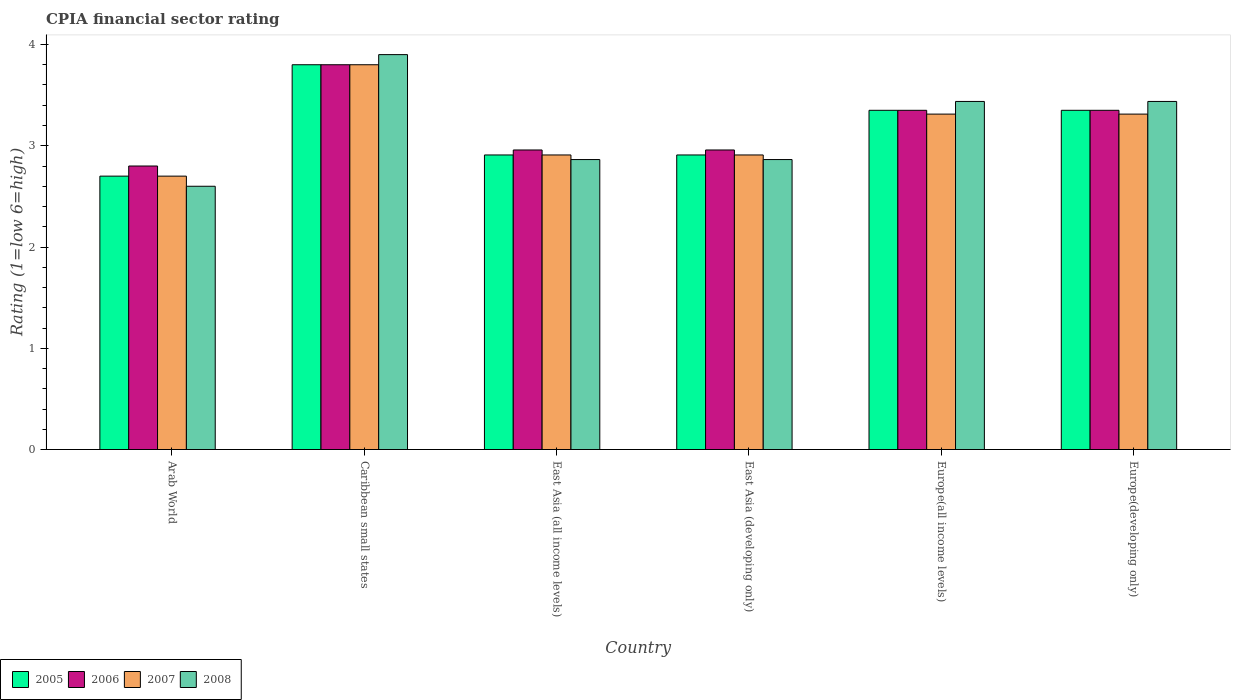How many groups of bars are there?
Give a very brief answer. 6. Are the number of bars per tick equal to the number of legend labels?
Keep it short and to the point. Yes. Are the number of bars on each tick of the X-axis equal?
Offer a terse response. Yes. How many bars are there on the 2nd tick from the right?
Make the answer very short. 4. What is the label of the 6th group of bars from the left?
Offer a terse response. Europe(developing only). What is the CPIA rating in 2008 in Europe(developing only)?
Provide a succinct answer. 3.44. Across all countries, what is the minimum CPIA rating in 2005?
Your answer should be very brief. 2.7. In which country was the CPIA rating in 2008 maximum?
Provide a short and direct response. Caribbean small states. In which country was the CPIA rating in 2006 minimum?
Ensure brevity in your answer.  Arab World. What is the total CPIA rating in 2008 in the graph?
Offer a terse response. 19.1. What is the difference between the CPIA rating in 2008 in Europe(developing only) and the CPIA rating in 2005 in Caribbean small states?
Offer a terse response. -0.36. What is the average CPIA rating in 2005 per country?
Keep it short and to the point. 3.17. What is the difference between the CPIA rating of/in 2008 and CPIA rating of/in 2007 in East Asia (all income levels)?
Offer a terse response. -0.05. What is the ratio of the CPIA rating in 2006 in Arab World to that in Caribbean small states?
Give a very brief answer. 0.74. Is the difference between the CPIA rating in 2008 in Caribbean small states and Europe(developing only) greater than the difference between the CPIA rating in 2007 in Caribbean small states and Europe(developing only)?
Keep it short and to the point. No. What is the difference between the highest and the second highest CPIA rating in 2008?
Give a very brief answer. -0.46. What is the difference between the highest and the lowest CPIA rating in 2005?
Your response must be concise. 1.1. Is the sum of the CPIA rating in 2006 in Arab World and Europe(all income levels) greater than the maximum CPIA rating in 2008 across all countries?
Provide a short and direct response. Yes. Is it the case that in every country, the sum of the CPIA rating in 2008 and CPIA rating in 2006 is greater than the sum of CPIA rating in 2007 and CPIA rating in 2005?
Provide a succinct answer. No. What does the 2nd bar from the left in East Asia (all income levels) represents?
Give a very brief answer. 2006. What does the 2nd bar from the right in Europe(developing only) represents?
Make the answer very short. 2007. How many bars are there?
Your response must be concise. 24. What is the difference between two consecutive major ticks on the Y-axis?
Make the answer very short. 1. Does the graph contain grids?
Your response must be concise. No. How are the legend labels stacked?
Keep it short and to the point. Horizontal. What is the title of the graph?
Make the answer very short. CPIA financial sector rating. Does "2003" appear as one of the legend labels in the graph?
Offer a terse response. No. What is the label or title of the X-axis?
Ensure brevity in your answer.  Country. What is the Rating (1=low 6=high) of 2005 in Arab World?
Offer a very short reply. 2.7. What is the Rating (1=low 6=high) of 2006 in Caribbean small states?
Give a very brief answer. 3.8. What is the Rating (1=low 6=high) of 2005 in East Asia (all income levels)?
Offer a terse response. 2.91. What is the Rating (1=low 6=high) in 2006 in East Asia (all income levels)?
Keep it short and to the point. 2.96. What is the Rating (1=low 6=high) in 2007 in East Asia (all income levels)?
Provide a short and direct response. 2.91. What is the Rating (1=low 6=high) in 2008 in East Asia (all income levels)?
Offer a terse response. 2.86. What is the Rating (1=low 6=high) of 2005 in East Asia (developing only)?
Provide a short and direct response. 2.91. What is the Rating (1=low 6=high) of 2006 in East Asia (developing only)?
Give a very brief answer. 2.96. What is the Rating (1=low 6=high) of 2007 in East Asia (developing only)?
Keep it short and to the point. 2.91. What is the Rating (1=low 6=high) of 2008 in East Asia (developing only)?
Offer a very short reply. 2.86. What is the Rating (1=low 6=high) of 2005 in Europe(all income levels)?
Give a very brief answer. 3.35. What is the Rating (1=low 6=high) in 2006 in Europe(all income levels)?
Provide a short and direct response. 3.35. What is the Rating (1=low 6=high) in 2007 in Europe(all income levels)?
Offer a terse response. 3.31. What is the Rating (1=low 6=high) in 2008 in Europe(all income levels)?
Offer a very short reply. 3.44. What is the Rating (1=low 6=high) of 2005 in Europe(developing only)?
Your response must be concise. 3.35. What is the Rating (1=low 6=high) in 2006 in Europe(developing only)?
Your answer should be very brief. 3.35. What is the Rating (1=low 6=high) of 2007 in Europe(developing only)?
Your answer should be compact. 3.31. What is the Rating (1=low 6=high) in 2008 in Europe(developing only)?
Provide a short and direct response. 3.44. Across all countries, what is the maximum Rating (1=low 6=high) in 2007?
Give a very brief answer. 3.8. Across all countries, what is the maximum Rating (1=low 6=high) of 2008?
Give a very brief answer. 3.9. Across all countries, what is the minimum Rating (1=low 6=high) in 2005?
Offer a terse response. 2.7. Across all countries, what is the minimum Rating (1=low 6=high) of 2008?
Your answer should be very brief. 2.6. What is the total Rating (1=low 6=high) in 2005 in the graph?
Make the answer very short. 19.02. What is the total Rating (1=low 6=high) of 2006 in the graph?
Keep it short and to the point. 19.22. What is the total Rating (1=low 6=high) of 2007 in the graph?
Your response must be concise. 18.94. What is the total Rating (1=low 6=high) in 2008 in the graph?
Your answer should be compact. 19.1. What is the difference between the Rating (1=low 6=high) in 2007 in Arab World and that in Caribbean small states?
Keep it short and to the point. -1.1. What is the difference between the Rating (1=low 6=high) in 2008 in Arab World and that in Caribbean small states?
Your response must be concise. -1.3. What is the difference between the Rating (1=low 6=high) in 2005 in Arab World and that in East Asia (all income levels)?
Your response must be concise. -0.21. What is the difference between the Rating (1=low 6=high) in 2006 in Arab World and that in East Asia (all income levels)?
Provide a succinct answer. -0.16. What is the difference between the Rating (1=low 6=high) in 2007 in Arab World and that in East Asia (all income levels)?
Ensure brevity in your answer.  -0.21. What is the difference between the Rating (1=low 6=high) in 2008 in Arab World and that in East Asia (all income levels)?
Give a very brief answer. -0.26. What is the difference between the Rating (1=low 6=high) of 2005 in Arab World and that in East Asia (developing only)?
Provide a succinct answer. -0.21. What is the difference between the Rating (1=low 6=high) of 2006 in Arab World and that in East Asia (developing only)?
Your answer should be very brief. -0.16. What is the difference between the Rating (1=low 6=high) of 2007 in Arab World and that in East Asia (developing only)?
Your answer should be very brief. -0.21. What is the difference between the Rating (1=low 6=high) in 2008 in Arab World and that in East Asia (developing only)?
Provide a short and direct response. -0.26. What is the difference between the Rating (1=low 6=high) in 2005 in Arab World and that in Europe(all income levels)?
Provide a succinct answer. -0.65. What is the difference between the Rating (1=low 6=high) of 2006 in Arab World and that in Europe(all income levels)?
Keep it short and to the point. -0.55. What is the difference between the Rating (1=low 6=high) in 2007 in Arab World and that in Europe(all income levels)?
Your answer should be compact. -0.61. What is the difference between the Rating (1=low 6=high) of 2008 in Arab World and that in Europe(all income levels)?
Your answer should be compact. -0.84. What is the difference between the Rating (1=low 6=high) in 2005 in Arab World and that in Europe(developing only)?
Provide a short and direct response. -0.65. What is the difference between the Rating (1=low 6=high) in 2006 in Arab World and that in Europe(developing only)?
Provide a short and direct response. -0.55. What is the difference between the Rating (1=low 6=high) in 2007 in Arab World and that in Europe(developing only)?
Your answer should be very brief. -0.61. What is the difference between the Rating (1=low 6=high) of 2008 in Arab World and that in Europe(developing only)?
Your response must be concise. -0.84. What is the difference between the Rating (1=low 6=high) in 2005 in Caribbean small states and that in East Asia (all income levels)?
Offer a very short reply. 0.89. What is the difference between the Rating (1=low 6=high) in 2006 in Caribbean small states and that in East Asia (all income levels)?
Your answer should be very brief. 0.84. What is the difference between the Rating (1=low 6=high) in 2007 in Caribbean small states and that in East Asia (all income levels)?
Your answer should be compact. 0.89. What is the difference between the Rating (1=low 6=high) of 2008 in Caribbean small states and that in East Asia (all income levels)?
Keep it short and to the point. 1.04. What is the difference between the Rating (1=low 6=high) in 2005 in Caribbean small states and that in East Asia (developing only)?
Keep it short and to the point. 0.89. What is the difference between the Rating (1=low 6=high) in 2006 in Caribbean small states and that in East Asia (developing only)?
Give a very brief answer. 0.84. What is the difference between the Rating (1=low 6=high) of 2007 in Caribbean small states and that in East Asia (developing only)?
Make the answer very short. 0.89. What is the difference between the Rating (1=low 6=high) of 2008 in Caribbean small states and that in East Asia (developing only)?
Provide a succinct answer. 1.04. What is the difference between the Rating (1=low 6=high) of 2005 in Caribbean small states and that in Europe(all income levels)?
Ensure brevity in your answer.  0.45. What is the difference between the Rating (1=low 6=high) of 2006 in Caribbean small states and that in Europe(all income levels)?
Keep it short and to the point. 0.45. What is the difference between the Rating (1=low 6=high) of 2007 in Caribbean small states and that in Europe(all income levels)?
Your answer should be very brief. 0.49. What is the difference between the Rating (1=low 6=high) in 2008 in Caribbean small states and that in Europe(all income levels)?
Provide a short and direct response. 0.46. What is the difference between the Rating (1=low 6=high) in 2005 in Caribbean small states and that in Europe(developing only)?
Provide a short and direct response. 0.45. What is the difference between the Rating (1=low 6=high) of 2006 in Caribbean small states and that in Europe(developing only)?
Ensure brevity in your answer.  0.45. What is the difference between the Rating (1=low 6=high) of 2007 in Caribbean small states and that in Europe(developing only)?
Offer a very short reply. 0.49. What is the difference between the Rating (1=low 6=high) in 2008 in Caribbean small states and that in Europe(developing only)?
Offer a terse response. 0.46. What is the difference between the Rating (1=low 6=high) of 2005 in East Asia (all income levels) and that in East Asia (developing only)?
Offer a terse response. 0. What is the difference between the Rating (1=low 6=high) in 2006 in East Asia (all income levels) and that in East Asia (developing only)?
Ensure brevity in your answer.  0. What is the difference between the Rating (1=low 6=high) in 2007 in East Asia (all income levels) and that in East Asia (developing only)?
Keep it short and to the point. 0. What is the difference between the Rating (1=low 6=high) of 2008 in East Asia (all income levels) and that in East Asia (developing only)?
Offer a very short reply. 0. What is the difference between the Rating (1=low 6=high) in 2005 in East Asia (all income levels) and that in Europe(all income levels)?
Provide a succinct answer. -0.44. What is the difference between the Rating (1=low 6=high) in 2006 in East Asia (all income levels) and that in Europe(all income levels)?
Your answer should be very brief. -0.39. What is the difference between the Rating (1=low 6=high) in 2007 in East Asia (all income levels) and that in Europe(all income levels)?
Offer a terse response. -0.4. What is the difference between the Rating (1=low 6=high) of 2008 in East Asia (all income levels) and that in Europe(all income levels)?
Offer a very short reply. -0.57. What is the difference between the Rating (1=low 6=high) in 2005 in East Asia (all income levels) and that in Europe(developing only)?
Offer a terse response. -0.44. What is the difference between the Rating (1=low 6=high) of 2006 in East Asia (all income levels) and that in Europe(developing only)?
Your answer should be compact. -0.39. What is the difference between the Rating (1=low 6=high) of 2007 in East Asia (all income levels) and that in Europe(developing only)?
Offer a terse response. -0.4. What is the difference between the Rating (1=low 6=high) of 2008 in East Asia (all income levels) and that in Europe(developing only)?
Ensure brevity in your answer.  -0.57. What is the difference between the Rating (1=low 6=high) of 2005 in East Asia (developing only) and that in Europe(all income levels)?
Offer a terse response. -0.44. What is the difference between the Rating (1=low 6=high) in 2006 in East Asia (developing only) and that in Europe(all income levels)?
Give a very brief answer. -0.39. What is the difference between the Rating (1=low 6=high) in 2007 in East Asia (developing only) and that in Europe(all income levels)?
Your answer should be very brief. -0.4. What is the difference between the Rating (1=low 6=high) of 2008 in East Asia (developing only) and that in Europe(all income levels)?
Make the answer very short. -0.57. What is the difference between the Rating (1=low 6=high) of 2005 in East Asia (developing only) and that in Europe(developing only)?
Offer a very short reply. -0.44. What is the difference between the Rating (1=low 6=high) in 2006 in East Asia (developing only) and that in Europe(developing only)?
Provide a succinct answer. -0.39. What is the difference between the Rating (1=low 6=high) in 2007 in East Asia (developing only) and that in Europe(developing only)?
Offer a terse response. -0.4. What is the difference between the Rating (1=low 6=high) of 2008 in East Asia (developing only) and that in Europe(developing only)?
Your answer should be very brief. -0.57. What is the difference between the Rating (1=low 6=high) of 2008 in Europe(all income levels) and that in Europe(developing only)?
Offer a terse response. 0. What is the difference between the Rating (1=low 6=high) of 2005 in Arab World and the Rating (1=low 6=high) of 2006 in Caribbean small states?
Your response must be concise. -1.1. What is the difference between the Rating (1=low 6=high) in 2006 in Arab World and the Rating (1=low 6=high) in 2007 in Caribbean small states?
Keep it short and to the point. -1. What is the difference between the Rating (1=low 6=high) in 2005 in Arab World and the Rating (1=low 6=high) in 2006 in East Asia (all income levels)?
Ensure brevity in your answer.  -0.26. What is the difference between the Rating (1=low 6=high) in 2005 in Arab World and the Rating (1=low 6=high) in 2007 in East Asia (all income levels)?
Give a very brief answer. -0.21. What is the difference between the Rating (1=low 6=high) of 2005 in Arab World and the Rating (1=low 6=high) of 2008 in East Asia (all income levels)?
Provide a succinct answer. -0.16. What is the difference between the Rating (1=low 6=high) in 2006 in Arab World and the Rating (1=low 6=high) in 2007 in East Asia (all income levels)?
Your answer should be compact. -0.11. What is the difference between the Rating (1=low 6=high) in 2006 in Arab World and the Rating (1=low 6=high) in 2008 in East Asia (all income levels)?
Keep it short and to the point. -0.06. What is the difference between the Rating (1=low 6=high) of 2007 in Arab World and the Rating (1=low 6=high) of 2008 in East Asia (all income levels)?
Provide a short and direct response. -0.16. What is the difference between the Rating (1=low 6=high) of 2005 in Arab World and the Rating (1=low 6=high) of 2006 in East Asia (developing only)?
Offer a very short reply. -0.26. What is the difference between the Rating (1=low 6=high) in 2005 in Arab World and the Rating (1=low 6=high) in 2007 in East Asia (developing only)?
Offer a terse response. -0.21. What is the difference between the Rating (1=low 6=high) of 2005 in Arab World and the Rating (1=low 6=high) of 2008 in East Asia (developing only)?
Your answer should be compact. -0.16. What is the difference between the Rating (1=low 6=high) of 2006 in Arab World and the Rating (1=low 6=high) of 2007 in East Asia (developing only)?
Your answer should be compact. -0.11. What is the difference between the Rating (1=low 6=high) in 2006 in Arab World and the Rating (1=low 6=high) in 2008 in East Asia (developing only)?
Provide a succinct answer. -0.06. What is the difference between the Rating (1=low 6=high) of 2007 in Arab World and the Rating (1=low 6=high) of 2008 in East Asia (developing only)?
Your answer should be very brief. -0.16. What is the difference between the Rating (1=low 6=high) in 2005 in Arab World and the Rating (1=low 6=high) in 2006 in Europe(all income levels)?
Give a very brief answer. -0.65. What is the difference between the Rating (1=low 6=high) in 2005 in Arab World and the Rating (1=low 6=high) in 2007 in Europe(all income levels)?
Provide a short and direct response. -0.61. What is the difference between the Rating (1=low 6=high) of 2005 in Arab World and the Rating (1=low 6=high) of 2008 in Europe(all income levels)?
Offer a very short reply. -0.74. What is the difference between the Rating (1=low 6=high) in 2006 in Arab World and the Rating (1=low 6=high) in 2007 in Europe(all income levels)?
Offer a very short reply. -0.51. What is the difference between the Rating (1=low 6=high) of 2006 in Arab World and the Rating (1=low 6=high) of 2008 in Europe(all income levels)?
Your answer should be compact. -0.64. What is the difference between the Rating (1=low 6=high) of 2007 in Arab World and the Rating (1=low 6=high) of 2008 in Europe(all income levels)?
Provide a succinct answer. -0.74. What is the difference between the Rating (1=low 6=high) in 2005 in Arab World and the Rating (1=low 6=high) in 2006 in Europe(developing only)?
Ensure brevity in your answer.  -0.65. What is the difference between the Rating (1=low 6=high) of 2005 in Arab World and the Rating (1=low 6=high) of 2007 in Europe(developing only)?
Make the answer very short. -0.61. What is the difference between the Rating (1=low 6=high) of 2005 in Arab World and the Rating (1=low 6=high) of 2008 in Europe(developing only)?
Offer a terse response. -0.74. What is the difference between the Rating (1=low 6=high) in 2006 in Arab World and the Rating (1=low 6=high) in 2007 in Europe(developing only)?
Your answer should be very brief. -0.51. What is the difference between the Rating (1=low 6=high) in 2006 in Arab World and the Rating (1=low 6=high) in 2008 in Europe(developing only)?
Your response must be concise. -0.64. What is the difference between the Rating (1=low 6=high) of 2007 in Arab World and the Rating (1=low 6=high) of 2008 in Europe(developing only)?
Your answer should be compact. -0.74. What is the difference between the Rating (1=low 6=high) in 2005 in Caribbean small states and the Rating (1=low 6=high) in 2006 in East Asia (all income levels)?
Your response must be concise. 0.84. What is the difference between the Rating (1=low 6=high) in 2005 in Caribbean small states and the Rating (1=low 6=high) in 2007 in East Asia (all income levels)?
Provide a short and direct response. 0.89. What is the difference between the Rating (1=low 6=high) in 2005 in Caribbean small states and the Rating (1=low 6=high) in 2008 in East Asia (all income levels)?
Provide a succinct answer. 0.94. What is the difference between the Rating (1=low 6=high) of 2006 in Caribbean small states and the Rating (1=low 6=high) of 2007 in East Asia (all income levels)?
Make the answer very short. 0.89. What is the difference between the Rating (1=low 6=high) in 2006 in Caribbean small states and the Rating (1=low 6=high) in 2008 in East Asia (all income levels)?
Give a very brief answer. 0.94. What is the difference between the Rating (1=low 6=high) in 2007 in Caribbean small states and the Rating (1=low 6=high) in 2008 in East Asia (all income levels)?
Offer a very short reply. 0.94. What is the difference between the Rating (1=low 6=high) of 2005 in Caribbean small states and the Rating (1=low 6=high) of 2006 in East Asia (developing only)?
Ensure brevity in your answer.  0.84. What is the difference between the Rating (1=low 6=high) of 2005 in Caribbean small states and the Rating (1=low 6=high) of 2007 in East Asia (developing only)?
Your answer should be compact. 0.89. What is the difference between the Rating (1=low 6=high) of 2005 in Caribbean small states and the Rating (1=low 6=high) of 2008 in East Asia (developing only)?
Offer a terse response. 0.94. What is the difference between the Rating (1=low 6=high) in 2006 in Caribbean small states and the Rating (1=low 6=high) in 2007 in East Asia (developing only)?
Ensure brevity in your answer.  0.89. What is the difference between the Rating (1=low 6=high) in 2006 in Caribbean small states and the Rating (1=low 6=high) in 2008 in East Asia (developing only)?
Your answer should be compact. 0.94. What is the difference between the Rating (1=low 6=high) of 2007 in Caribbean small states and the Rating (1=low 6=high) of 2008 in East Asia (developing only)?
Offer a very short reply. 0.94. What is the difference between the Rating (1=low 6=high) in 2005 in Caribbean small states and the Rating (1=low 6=high) in 2006 in Europe(all income levels)?
Your response must be concise. 0.45. What is the difference between the Rating (1=low 6=high) of 2005 in Caribbean small states and the Rating (1=low 6=high) of 2007 in Europe(all income levels)?
Your response must be concise. 0.49. What is the difference between the Rating (1=low 6=high) in 2005 in Caribbean small states and the Rating (1=low 6=high) in 2008 in Europe(all income levels)?
Provide a succinct answer. 0.36. What is the difference between the Rating (1=low 6=high) of 2006 in Caribbean small states and the Rating (1=low 6=high) of 2007 in Europe(all income levels)?
Give a very brief answer. 0.49. What is the difference between the Rating (1=low 6=high) of 2006 in Caribbean small states and the Rating (1=low 6=high) of 2008 in Europe(all income levels)?
Your response must be concise. 0.36. What is the difference between the Rating (1=low 6=high) of 2007 in Caribbean small states and the Rating (1=low 6=high) of 2008 in Europe(all income levels)?
Keep it short and to the point. 0.36. What is the difference between the Rating (1=low 6=high) of 2005 in Caribbean small states and the Rating (1=low 6=high) of 2006 in Europe(developing only)?
Your answer should be compact. 0.45. What is the difference between the Rating (1=low 6=high) of 2005 in Caribbean small states and the Rating (1=low 6=high) of 2007 in Europe(developing only)?
Make the answer very short. 0.49. What is the difference between the Rating (1=low 6=high) of 2005 in Caribbean small states and the Rating (1=low 6=high) of 2008 in Europe(developing only)?
Keep it short and to the point. 0.36. What is the difference between the Rating (1=low 6=high) in 2006 in Caribbean small states and the Rating (1=low 6=high) in 2007 in Europe(developing only)?
Keep it short and to the point. 0.49. What is the difference between the Rating (1=low 6=high) of 2006 in Caribbean small states and the Rating (1=low 6=high) of 2008 in Europe(developing only)?
Provide a short and direct response. 0.36. What is the difference between the Rating (1=low 6=high) in 2007 in Caribbean small states and the Rating (1=low 6=high) in 2008 in Europe(developing only)?
Keep it short and to the point. 0.36. What is the difference between the Rating (1=low 6=high) of 2005 in East Asia (all income levels) and the Rating (1=low 6=high) of 2006 in East Asia (developing only)?
Offer a very short reply. -0.05. What is the difference between the Rating (1=low 6=high) of 2005 in East Asia (all income levels) and the Rating (1=low 6=high) of 2007 in East Asia (developing only)?
Offer a terse response. 0. What is the difference between the Rating (1=low 6=high) of 2005 in East Asia (all income levels) and the Rating (1=low 6=high) of 2008 in East Asia (developing only)?
Your answer should be very brief. 0.05. What is the difference between the Rating (1=low 6=high) of 2006 in East Asia (all income levels) and the Rating (1=low 6=high) of 2007 in East Asia (developing only)?
Offer a very short reply. 0.05. What is the difference between the Rating (1=low 6=high) of 2006 in East Asia (all income levels) and the Rating (1=low 6=high) of 2008 in East Asia (developing only)?
Keep it short and to the point. 0.09. What is the difference between the Rating (1=low 6=high) in 2007 in East Asia (all income levels) and the Rating (1=low 6=high) in 2008 in East Asia (developing only)?
Provide a short and direct response. 0.05. What is the difference between the Rating (1=low 6=high) of 2005 in East Asia (all income levels) and the Rating (1=low 6=high) of 2006 in Europe(all income levels)?
Provide a succinct answer. -0.44. What is the difference between the Rating (1=low 6=high) in 2005 in East Asia (all income levels) and the Rating (1=low 6=high) in 2007 in Europe(all income levels)?
Ensure brevity in your answer.  -0.4. What is the difference between the Rating (1=low 6=high) of 2005 in East Asia (all income levels) and the Rating (1=low 6=high) of 2008 in Europe(all income levels)?
Offer a terse response. -0.53. What is the difference between the Rating (1=low 6=high) of 2006 in East Asia (all income levels) and the Rating (1=low 6=high) of 2007 in Europe(all income levels)?
Your response must be concise. -0.35. What is the difference between the Rating (1=low 6=high) in 2006 in East Asia (all income levels) and the Rating (1=low 6=high) in 2008 in Europe(all income levels)?
Your response must be concise. -0.48. What is the difference between the Rating (1=low 6=high) of 2007 in East Asia (all income levels) and the Rating (1=low 6=high) of 2008 in Europe(all income levels)?
Your response must be concise. -0.53. What is the difference between the Rating (1=low 6=high) of 2005 in East Asia (all income levels) and the Rating (1=low 6=high) of 2006 in Europe(developing only)?
Keep it short and to the point. -0.44. What is the difference between the Rating (1=low 6=high) of 2005 in East Asia (all income levels) and the Rating (1=low 6=high) of 2007 in Europe(developing only)?
Your response must be concise. -0.4. What is the difference between the Rating (1=low 6=high) of 2005 in East Asia (all income levels) and the Rating (1=low 6=high) of 2008 in Europe(developing only)?
Give a very brief answer. -0.53. What is the difference between the Rating (1=low 6=high) in 2006 in East Asia (all income levels) and the Rating (1=low 6=high) in 2007 in Europe(developing only)?
Give a very brief answer. -0.35. What is the difference between the Rating (1=low 6=high) of 2006 in East Asia (all income levels) and the Rating (1=low 6=high) of 2008 in Europe(developing only)?
Give a very brief answer. -0.48. What is the difference between the Rating (1=low 6=high) in 2007 in East Asia (all income levels) and the Rating (1=low 6=high) in 2008 in Europe(developing only)?
Offer a very short reply. -0.53. What is the difference between the Rating (1=low 6=high) of 2005 in East Asia (developing only) and the Rating (1=low 6=high) of 2006 in Europe(all income levels)?
Your answer should be compact. -0.44. What is the difference between the Rating (1=low 6=high) in 2005 in East Asia (developing only) and the Rating (1=low 6=high) in 2007 in Europe(all income levels)?
Keep it short and to the point. -0.4. What is the difference between the Rating (1=low 6=high) of 2005 in East Asia (developing only) and the Rating (1=low 6=high) of 2008 in Europe(all income levels)?
Offer a very short reply. -0.53. What is the difference between the Rating (1=low 6=high) in 2006 in East Asia (developing only) and the Rating (1=low 6=high) in 2007 in Europe(all income levels)?
Offer a very short reply. -0.35. What is the difference between the Rating (1=low 6=high) in 2006 in East Asia (developing only) and the Rating (1=low 6=high) in 2008 in Europe(all income levels)?
Offer a very short reply. -0.48. What is the difference between the Rating (1=low 6=high) of 2007 in East Asia (developing only) and the Rating (1=low 6=high) of 2008 in Europe(all income levels)?
Make the answer very short. -0.53. What is the difference between the Rating (1=low 6=high) in 2005 in East Asia (developing only) and the Rating (1=low 6=high) in 2006 in Europe(developing only)?
Offer a terse response. -0.44. What is the difference between the Rating (1=low 6=high) of 2005 in East Asia (developing only) and the Rating (1=low 6=high) of 2007 in Europe(developing only)?
Give a very brief answer. -0.4. What is the difference between the Rating (1=low 6=high) in 2005 in East Asia (developing only) and the Rating (1=low 6=high) in 2008 in Europe(developing only)?
Provide a succinct answer. -0.53. What is the difference between the Rating (1=low 6=high) in 2006 in East Asia (developing only) and the Rating (1=low 6=high) in 2007 in Europe(developing only)?
Your answer should be very brief. -0.35. What is the difference between the Rating (1=low 6=high) of 2006 in East Asia (developing only) and the Rating (1=low 6=high) of 2008 in Europe(developing only)?
Make the answer very short. -0.48. What is the difference between the Rating (1=low 6=high) in 2007 in East Asia (developing only) and the Rating (1=low 6=high) in 2008 in Europe(developing only)?
Provide a short and direct response. -0.53. What is the difference between the Rating (1=low 6=high) of 2005 in Europe(all income levels) and the Rating (1=low 6=high) of 2007 in Europe(developing only)?
Ensure brevity in your answer.  0.04. What is the difference between the Rating (1=low 6=high) in 2005 in Europe(all income levels) and the Rating (1=low 6=high) in 2008 in Europe(developing only)?
Provide a short and direct response. -0.09. What is the difference between the Rating (1=low 6=high) of 2006 in Europe(all income levels) and the Rating (1=low 6=high) of 2007 in Europe(developing only)?
Your answer should be very brief. 0.04. What is the difference between the Rating (1=low 6=high) of 2006 in Europe(all income levels) and the Rating (1=low 6=high) of 2008 in Europe(developing only)?
Your response must be concise. -0.09. What is the difference between the Rating (1=low 6=high) of 2007 in Europe(all income levels) and the Rating (1=low 6=high) of 2008 in Europe(developing only)?
Your answer should be very brief. -0.12. What is the average Rating (1=low 6=high) in 2005 per country?
Offer a very short reply. 3.17. What is the average Rating (1=low 6=high) of 2006 per country?
Your answer should be compact. 3.2. What is the average Rating (1=low 6=high) of 2007 per country?
Give a very brief answer. 3.16. What is the average Rating (1=low 6=high) in 2008 per country?
Give a very brief answer. 3.18. What is the difference between the Rating (1=low 6=high) of 2005 and Rating (1=low 6=high) of 2006 in Arab World?
Ensure brevity in your answer.  -0.1. What is the difference between the Rating (1=low 6=high) of 2005 and Rating (1=low 6=high) of 2008 in Arab World?
Ensure brevity in your answer.  0.1. What is the difference between the Rating (1=low 6=high) of 2006 and Rating (1=low 6=high) of 2007 in Arab World?
Give a very brief answer. 0.1. What is the difference between the Rating (1=low 6=high) in 2006 and Rating (1=low 6=high) in 2008 in Arab World?
Make the answer very short. 0.2. What is the difference between the Rating (1=low 6=high) in 2007 and Rating (1=low 6=high) in 2008 in Arab World?
Keep it short and to the point. 0.1. What is the difference between the Rating (1=low 6=high) of 2005 and Rating (1=low 6=high) of 2006 in Caribbean small states?
Offer a terse response. 0. What is the difference between the Rating (1=low 6=high) in 2005 and Rating (1=low 6=high) in 2007 in Caribbean small states?
Give a very brief answer. 0. What is the difference between the Rating (1=low 6=high) of 2005 and Rating (1=low 6=high) of 2008 in Caribbean small states?
Provide a short and direct response. -0.1. What is the difference between the Rating (1=low 6=high) in 2006 and Rating (1=low 6=high) in 2008 in Caribbean small states?
Your answer should be compact. -0.1. What is the difference between the Rating (1=low 6=high) in 2007 and Rating (1=low 6=high) in 2008 in Caribbean small states?
Offer a terse response. -0.1. What is the difference between the Rating (1=low 6=high) in 2005 and Rating (1=low 6=high) in 2006 in East Asia (all income levels)?
Your answer should be very brief. -0.05. What is the difference between the Rating (1=low 6=high) in 2005 and Rating (1=low 6=high) in 2008 in East Asia (all income levels)?
Your answer should be compact. 0.05. What is the difference between the Rating (1=low 6=high) of 2006 and Rating (1=low 6=high) of 2007 in East Asia (all income levels)?
Offer a very short reply. 0.05. What is the difference between the Rating (1=low 6=high) in 2006 and Rating (1=low 6=high) in 2008 in East Asia (all income levels)?
Offer a terse response. 0.09. What is the difference between the Rating (1=low 6=high) of 2007 and Rating (1=low 6=high) of 2008 in East Asia (all income levels)?
Your response must be concise. 0.05. What is the difference between the Rating (1=low 6=high) in 2005 and Rating (1=low 6=high) in 2006 in East Asia (developing only)?
Ensure brevity in your answer.  -0.05. What is the difference between the Rating (1=low 6=high) in 2005 and Rating (1=low 6=high) in 2007 in East Asia (developing only)?
Make the answer very short. 0. What is the difference between the Rating (1=low 6=high) of 2005 and Rating (1=low 6=high) of 2008 in East Asia (developing only)?
Your answer should be very brief. 0.05. What is the difference between the Rating (1=low 6=high) of 2006 and Rating (1=low 6=high) of 2007 in East Asia (developing only)?
Your answer should be compact. 0.05. What is the difference between the Rating (1=low 6=high) in 2006 and Rating (1=low 6=high) in 2008 in East Asia (developing only)?
Keep it short and to the point. 0.09. What is the difference between the Rating (1=low 6=high) in 2007 and Rating (1=low 6=high) in 2008 in East Asia (developing only)?
Offer a very short reply. 0.05. What is the difference between the Rating (1=low 6=high) in 2005 and Rating (1=low 6=high) in 2007 in Europe(all income levels)?
Provide a short and direct response. 0.04. What is the difference between the Rating (1=low 6=high) of 2005 and Rating (1=low 6=high) of 2008 in Europe(all income levels)?
Keep it short and to the point. -0.09. What is the difference between the Rating (1=low 6=high) of 2006 and Rating (1=low 6=high) of 2007 in Europe(all income levels)?
Make the answer very short. 0.04. What is the difference between the Rating (1=low 6=high) of 2006 and Rating (1=low 6=high) of 2008 in Europe(all income levels)?
Your response must be concise. -0.09. What is the difference between the Rating (1=low 6=high) in 2007 and Rating (1=low 6=high) in 2008 in Europe(all income levels)?
Give a very brief answer. -0.12. What is the difference between the Rating (1=low 6=high) of 2005 and Rating (1=low 6=high) of 2006 in Europe(developing only)?
Offer a terse response. 0. What is the difference between the Rating (1=low 6=high) of 2005 and Rating (1=low 6=high) of 2007 in Europe(developing only)?
Provide a succinct answer. 0.04. What is the difference between the Rating (1=low 6=high) of 2005 and Rating (1=low 6=high) of 2008 in Europe(developing only)?
Your answer should be very brief. -0.09. What is the difference between the Rating (1=low 6=high) in 2006 and Rating (1=low 6=high) in 2007 in Europe(developing only)?
Keep it short and to the point. 0.04. What is the difference between the Rating (1=low 6=high) of 2006 and Rating (1=low 6=high) of 2008 in Europe(developing only)?
Your answer should be very brief. -0.09. What is the difference between the Rating (1=low 6=high) in 2007 and Rating (1=low 6=high) in 2008 in Europe(developing only)?
Ensure brevity in your answer.  -0.12. What is the ratio of the Rating (1=low 6=high) of 2005 in Arab World to that in Caribbean small states?
Provide a short and direct response. 0.71. What is the ratio of the Rating (1=low 6=high) of 2006 in Arab World to that in Caribbean small states?
Your answer should be very brief. 0.74. What is the ratio of the Rating (1=low 6=high) in 2007 in Arab World to that in Caribbean small states?
Offer a very short reply. 0.71. What is the ratio of the Rating (1=low 6=high) in 2005 in Arab World to that in East Asia (all income levels)?
Your answer should be very brief. 0.93. What is the ratio of the Rating (1=low 6=high) in 2006 in Arab World to that in East Asia (all income levels)?
Provide a short and direct response. 0.95. What is the ratio of the Rating (1=low 6=high) in 2007 in Arab World to that in East Asia (all income levels)?
Give a very brief answer. 0.93. What is the ratio of the Rating (1=low 6=high) of 2008 in Arab World to that in East Asia (all income levels)?
Offer a terse response. 0.91. What is the ratio of the Rating (1=low 6=high) of 2005 in Arab World to that in East Asia (developing only)?
Give a very brief answer. 0.93. What is the ratio of the Rating (1=low 6=high) in 2006 in Arab World to that in East Asia (developing only)?
Ensure brevity in your answer.  0.95. What is the ratio of the Rating (1=low 6=high) in 2007 in Arab World to that in East Asia (developing only)?
Keep it short and to the point. 0.93. What is the ratio of the Rating (1=low 6=high) in 2008 in Arab World to that in East Asia (developing only)?
Provide a succinct answer. 0.91. What is the ratio of the Rating (1=low 6=high) of 2005 in Arab World to that in Europe(all income levels)?
Give a very brief answer. 0.81. What is the ratio of the Rating (1=low 6=high) in 2006 in Arab World to that in Europe(all income levels)?
Your answer should be compact. 0.84. What is the ratio of the Rating (1=low 6=high) of 2007 in Arab World to that in Europe(all income levels)?
Your answer should be very brief. 0.82. What is the ratio of the Rating (1=low 6=high) of 2008 in Arab World to that in Europe(all income levels)?
Your answer should be very brief. 0.76. What is the ratio of the Rating (1=low 6=high) of 2005 in Arab World to that in Europe(developing only)?
Make the answer very short. 0.81. What is the ratio of the Rating (1=low 6=high) in 2006 in Arab World to that in Europe(developing only)?
Give a very brief answer. 0.84. What is the ratio of the Rating (1=low 6=high) in 2007 in Arab World to that in Europe(developing only)?
Make the answer very short. 0.82. What is the ratio of the Rating (1=low 6=high) in 2008 in Arab World to that in Europe(developing only)?
Your answer should be compact. 0.76. What is the ratio of the Rating (1=low 6=high) in 2005 in Caribbean small states to that in East Asia (all income levels)?
Provide a short and direct response. 1.31. What is the ratio of the Rating (1=low 6=high) of 2006 in Caribbean small states to that in East Asia (all income levels)?
Your response must be concise. 1.28. What is the ratio of the Rating (1=low 6=high) of 2007 in Caribbean small states to that in East Asia (all income levels)?
Give a very brief answer. 1.31. What is the ratio of the Rating (1=low 6=high) of 2008 in Caribbean small states to that in East Asia (all income levels)?
Give a very brief answer. 1.36. What is the ratio of the Rating (1=low 6=high) in 2005 in Caribbean small states to that in East Asia (developing only)?
Provide a short and direct response. 1.31. What is the ratio of the Rating (1=low 6=high) in 2006 in Caribbean small states to that in East Asia (developing only)?
Your answer should be very brief. 1.28. What is the ratio of the Rating (1=low 6=high) of 2007 in Caribbean small states to that in East Asia (developing only)?
Provide a succinct answer. 1.31. What is the ratio of the Rating (1=low 6=high) in 2008 in Caribbean small states to that in East Asia (developing only)?
Provide a succinct answer. 1.36. What is the ratio of the Rating (1=low 6=high) of 2005 in Caribbean small states to that in Europe(all income levels)?
Ensure brevity in your answer.  1.13. What is the ratio of the Rating (1=low 6=high) in 2006 in Caribbean small states to that in Europe(all income levels)?
Your answer should be compact. 1.13. What is the ratio of the Rating (1=low 6=high) of 2007 in Caribbean small states to that in Europe(all income levels)?
Your answer should be very brief. 1.15. What is the ratio of the Rating (1=low 6=high) of 2008 in Caribbean small states to that in Europe(all income levels)?
Your answer should be very brief. 1.13. What is the ratio of the Rating (1=low 6=high) of 2005 in Caribbean small states to that in Europe(developing only)?
Provide a short and direct response. 1.13. What is the ratio of the Rating (1=low 6=high) of 2006 in Caribbean small states to that in Europe(developing only)?
Provide a short and direct response. 1.13. What is the ratio of the Rating (1=low 6=high) of 2007 in Caribbean small states to that in Europe(developing only)?
Make the answer very short. 1.15. What is the ratio of the Rating (1=low 6=high) in 2008 in Caribbean small states to that in Europe(developing only)?
Offer a terse response. 1.13. What is the ratio of the Rating (1=low 6=high) of 2008 in East Asia (all income levels) to that in East Asia (developing only)?
Make the answer very short. 1. What is the ratio of the Rating (1=low 6=high) in 2005 in East Asia (all income levels) to that in Europe(all income levels)?
Provide a short and direct response. 0.87. What is the ratio of the Rating (1=low 6=high) in 2006 in East Asia (all income levels) to that in Europe(all income levels)?
Provide a succinct answer. 0.88. What is the ratio of the Rating (1=low 6=high) of 2007 in East Asia (all income levels) to that in Europe(all income levels)?
Ensure brevity in your answer.  0.88. What is the ratio of the Rating (1=low 6=high) in 2008 in East Asia (all income levels) to that in Europe(all income levels)?
Your answer should be very brief. 0.83. What is the ratio of the Rating (1=low 6=high) in 2005 in East Asia (all income levels) to that in Europe(developing only)?
Your response must be concise. 0.87. What is the ratio of the Rating (1=low 6=high) of 2006 in East Asia (all income levels) to that in Europe(developing only)?
Your answer should be very brief. 0.88. What is the ratio of the Rating (1=low 6=high) in 2007 in East Asia (all income levels) to that in Europe(developing only)?
Your answer should be compact. 0.88. What is the ratio of the Rating (1=low 6=high) of 2008 in East Asia (all income levels) to that in Europe(developing only)?
Offer a terse response. 0.83. What is the ratio of the Rating (1=low 6=high) in 2005 in East Asia (developing only) to that in Europe(all income levels)?
Offer a very short reply. 0.87. What is the ratio of the Rating (1=low 6=high) in 2006 in East Asia (developing only) to that in Europe(all income levels)?
Your answer should be very brief. 0.88. What is the ratio of the Rating (1=low 6=high) of 2007 in East Asia (developing only) to that in Europe(all income levels)?
Your answer should be compact. 0.88. What is the ratio of the Rating (1=low 6=high) in 2008 in East Asia (developing only) to that in Europe(all income levels)?
Give a very brief answer. 0.83. What is the ratio of the Rating (1=low 6=high) of 2005 in East Asia (developing only) to that in Europe(developing only)?
Offer a very short reply. 0.87. What is the ratio of the Rating (1=low 6=high) in 2006 in East Asia (developing only) to that in Europe(developing only)?
Offer a very short reply. 0.88. What is the ratio of the Rating (1=low 6=high) of 2007 in East Asia (developing only) to that in Europe(developing only)?
Your response must be concise. 0.88. What is the ratio of the Rating (1=low 6=high) of 2008 in East Asia (developing only) to that in Europe(developing only)?
Ensure brevity in your answer.  0.83. What is the ratio of the Rating (1=low 6=high) in 2006 in Europe(all income levels) to that in Europe(developing only)?
Offer a very short reply. 1. What is the ratio of the Rating (1=low 6=high) of 2007 in Europe(all income levels) to that in Europe(developing only)?
Provide a short and direct response. 1. What is the ratio of the Rating (1=low 6=high) in 2008 in Europe(all income levels) to that in Europe(developing only)?
Your answer should be compact. 1. What is the difference between the highest and the second highest Rating (1=low 6=high) of 2005?
Provide a succinct answer. 0.45. What is the difference between the highest and the second highest Rating (1=low 6=high) of 2006?
Your answer should be compact. 0.45. What is the difference between the highest and the second highest Rating (1=low 6=high) in 2007?
Your answer should be compact. 0.49. What is the difference between the highest and the second highest Rating (1=low 6=high) of 2008?
Keep it short and to the point. 0.46. What is the difference between the highest and the lowest Rating (1=low 6=high) in 2007?
Your response must be concise. 1.1. What is the difference between the highest and the lowest Rating (1=low 6=high) of 2008?
Keep it short and to the point. 1.3. 